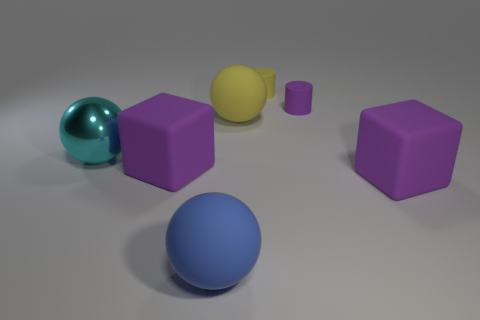Is there anything else that is made of the same material as the cyan ball?
Make the answer very short. No. Are any large cyan spheres visible?
Provide a short and direct response. Yes. How many other balls have the same color as the metal sphere?
Offer a terse response. 0. How big is the cube on the right side of the rubber cylinder in front of the tiny yellow rubber object?
Your response must be concise. Large. Is there another big cyan thing made of the same material as the cyan thing?
Your answer should be very brief. No. There is a yellow cylinder that is the same size as the purple matte cylinder; what is it made of?
Your response must be concise. Rubber. Is the color of the big matte object to the left of the big blue matte thing the same as the large metal sphere left of the small purple cylinder?
Give a very brief answer. No. Is there a yellow thing in front of the big ball that is in front of the metal ball?
Make the answer very short. No. Do the big purple rubber object that is to the right of the purple cylinder and the tiny purple matte object behind the yellow matte sphere have the same shape?
Give a very brief answer. No. Does the ball in front of the cyan metal sphere have the same material as the purple object to the left of the small yellow matte cylinder?
Provide a succinct answer. Yes. 